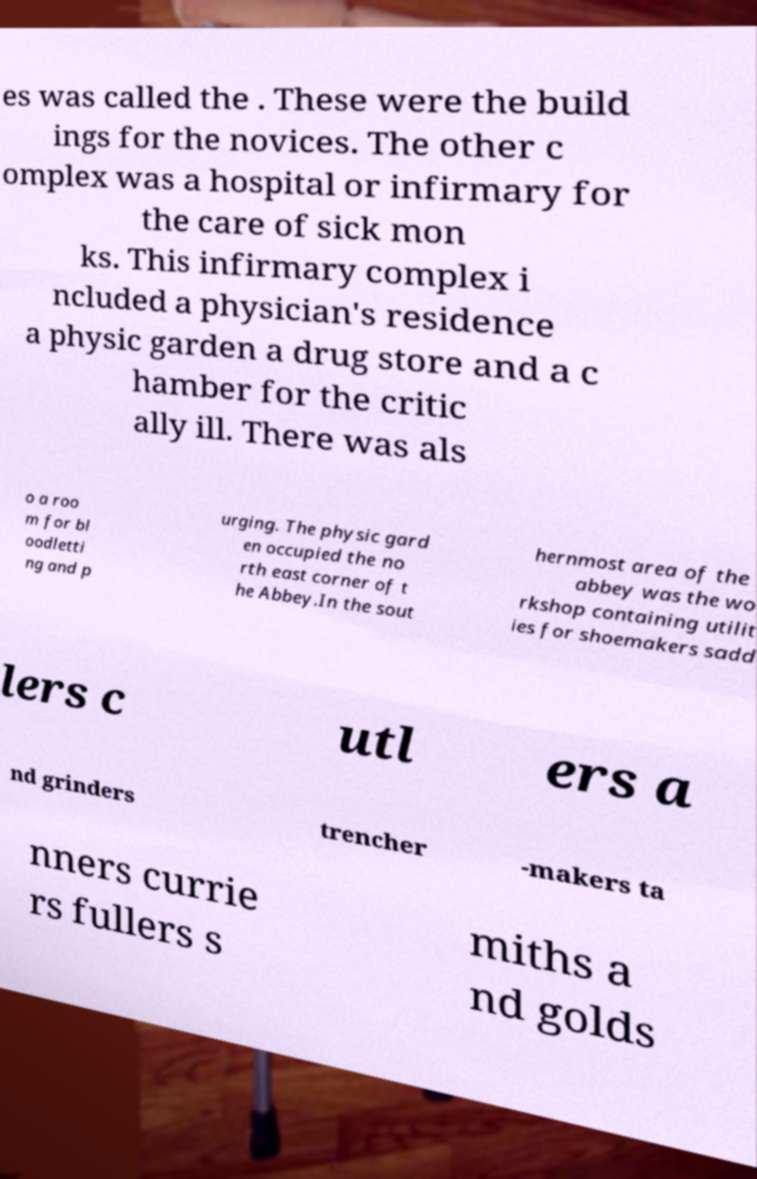What messages or text are displayed in this image? I need them in a readable, typed format. es was called the . These were the build ings for the novices. The other c omplex was a hospital or infirmary for the care of sick mon ks. This infirmary complex i ncluded a physician's residence a physic garden a drug store and a c hamber for the critic ally ill. There was als o a roo m for bl oodletti ng and p urging. The physic gard en occupied the no rth east corner of t he Abbey.In the sout hernmost area of the abbey was the wo rkshop containing utilit ies for shoemakers sadd lers c utl ers a nd grinders trencher -makers ta nners currie rs fullers s miths a nd golds 